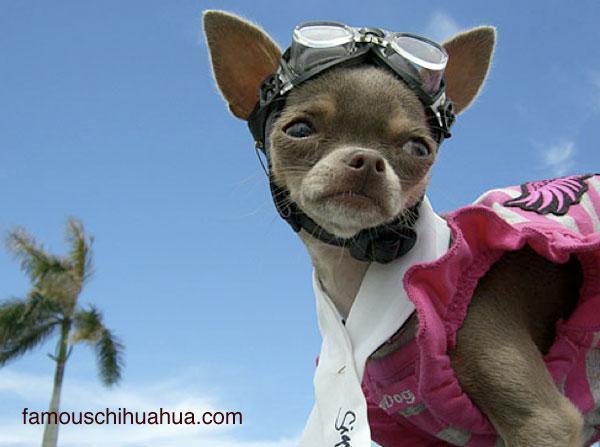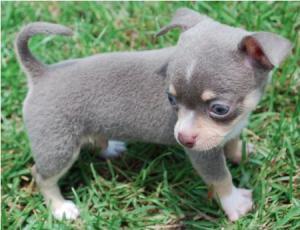The first image is the image on the left, the second image is the image on the right. Examine the images to the left and right. Is the description "One of the dogs is sticking it's tongue out of a closed mouth." accurate? Answer yes or no. No. 